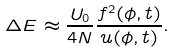Convert formula to latex. <formula><loc_0><loc_0><loc_500><loc_500>\Delta E \approx \frac { U _ { 0 } } { 4 N } \frac { f ^ { 2 } ( \phi , t ) } { u ( \phi , t ) } .</formula> 